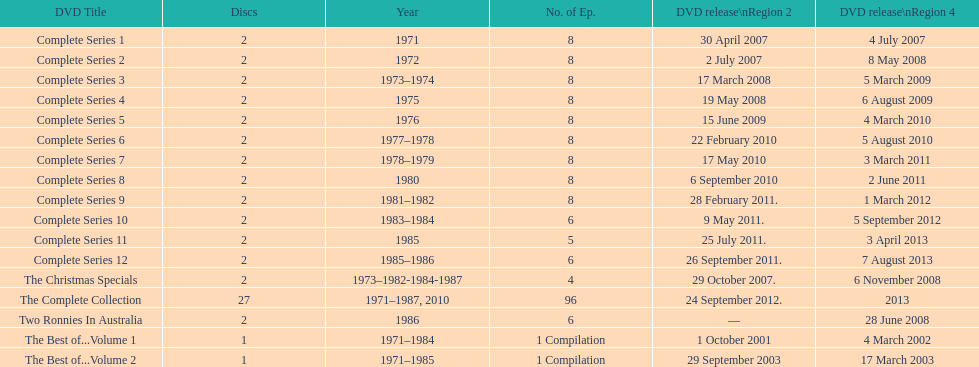What is the combined total of all discs presented in the table? 57. 